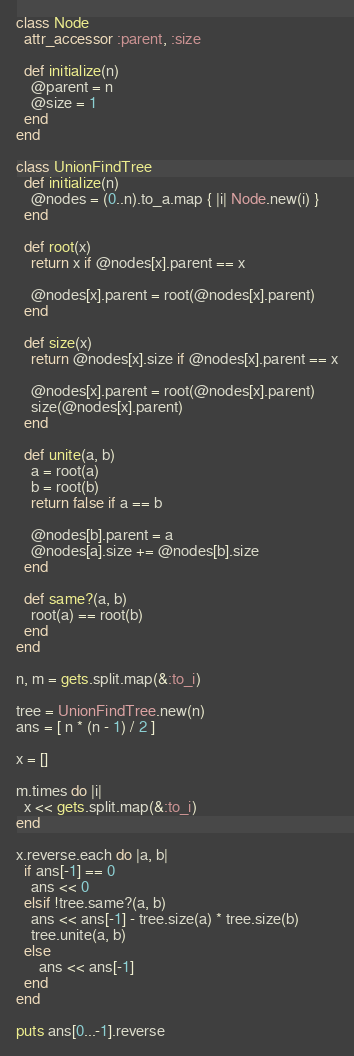<code> <loc_0><loc_0><loc_500><loc_500><_Ruby_>class Node
  attr_accessor :parent, :size

  def initialize(n)
    @parent = n
    @size = 1
  end
end

class UnionFindTree
  def initialize(n)
    @nodes = (0..n).to_a.map { |i| Node.new(i) }
  end

  def root(x)
    return x if @nodes[x].parent == x

    @nodes[x].parent = root(@nodes[x].parent)
  end

  def size(x)
    return @nodes[x].size if @nodes[x].parent == x

    @nodes[x].parent = root(@nodes[x].parent)
    size(@nodes[x].parent)
  end

  def unite(a, b)
    a = root(a)
    b = root(b)
    return false if a == b

    @nodes[b].parent = a
    @nodes[a].size += @nodes[b].size
  end

  def same?(a, b)
    root(a) == root(b)
  end
end

n, m = gets.split.map(&:to_i)

tree = UnionFindTree.new(n)
ans = [ n * (n - 1) / 2 ]

x = []

m.times do |i|
  x << gets.split.map(&:to_i)
end

x.reverse.each do |a, b|
  if ans[-1] == 0
    ans << 0
  elsif !tree.same?(a, b)
    ans << ans[-1] - tree.size(a) * tree.size(b)
    tree.unite(a, b)
  else
      ans << ans[-1]
  end
end

puts ans[0...-1].reverse</code> 